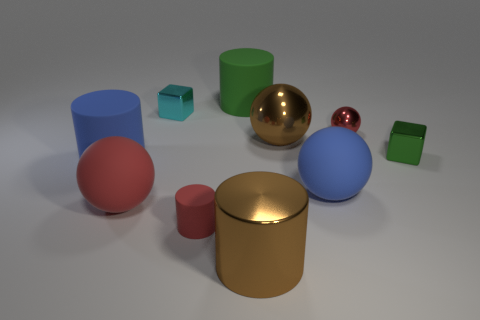Subtract all red balls. How many balls are left? 2 Subtract all big metallic balls. How many balls are left? 3 Subtract all cubes. How many objects are left? 8 Subtract 3 spheres. How many spheres are left? 1 Subtract all brown spheres. How many brown cylinders are left? 1 Subtract all tiny red spheres. Subtract all large green matte cylinders. How many objects are left? 8 Add 5 big red matte spheres. How many big red matte spheres are left? 6 Add 10 tiny purple matte cubes. How many tiny purple matte cubes exist? 10 Subtract 0 cyan balls. How many objects are left? 10 Subtract all green cylinders. Subtract all brown blocks. How many cylinders are left? 3 